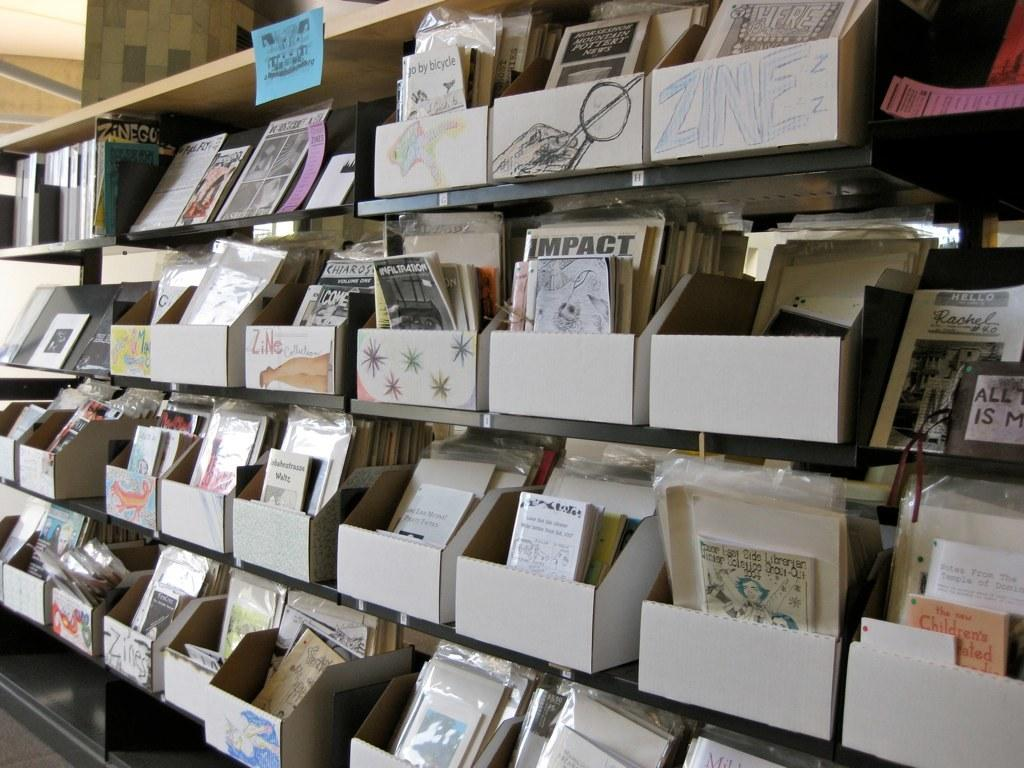What type of items can be seen in the shelves in the image? There are books in the shelves in the image. What is on the top of the shelves or an object? There is a blue note on the top of the shelves or an object. What type of meeting is taking place in the image? There is no indication of a meeting taking place in the image. Can you see anyone walking in the image? There is no indication of anyone walking in the image. Is there a volleyball visible in the image? There is no volleyball present in the image. 